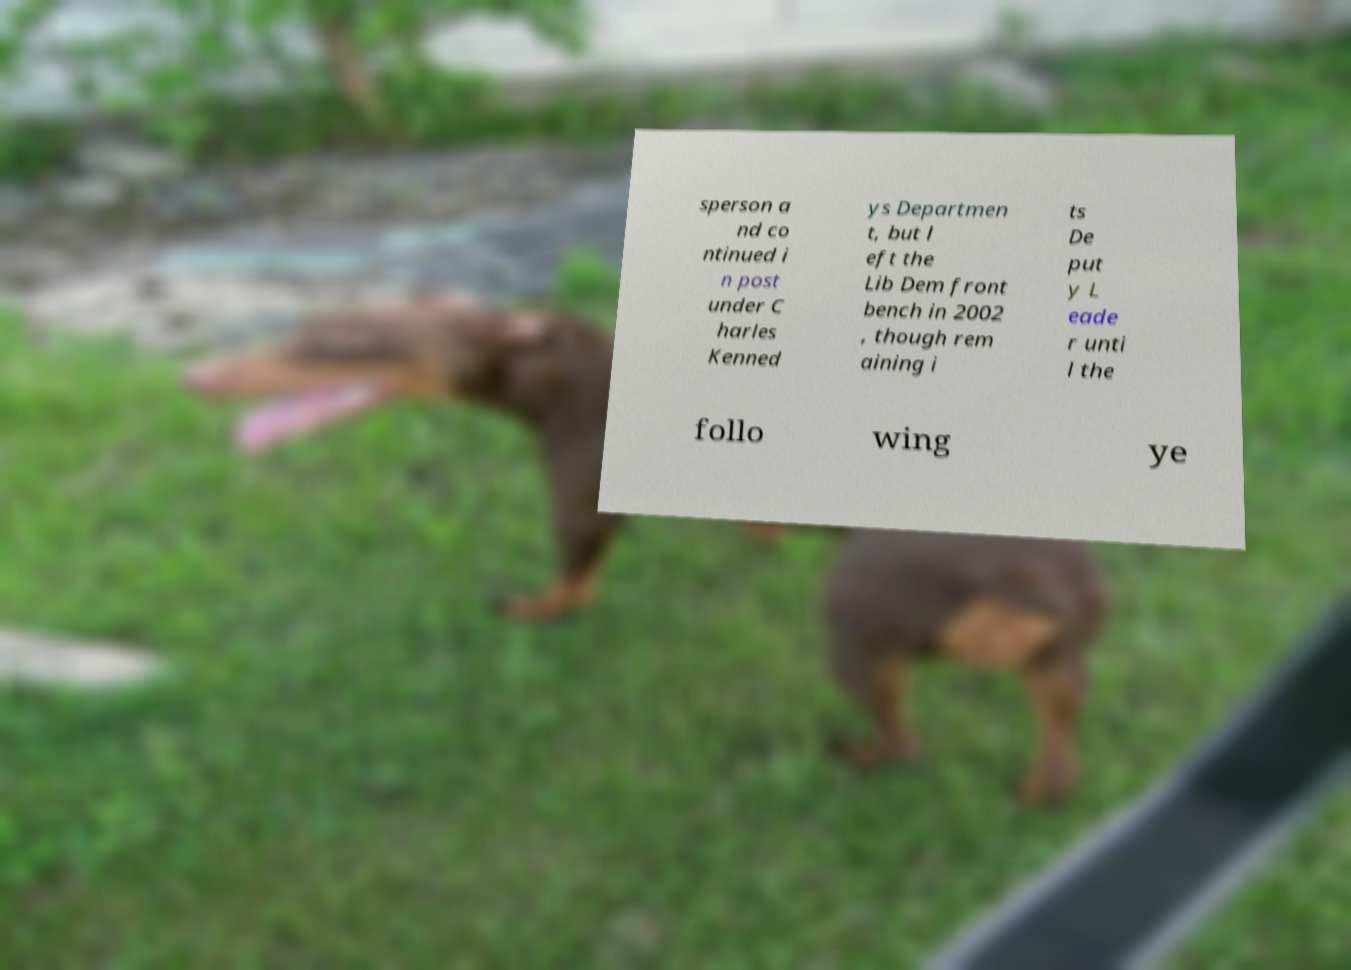For documentation purposes, I need the text within this image transcribed. Could you provide that? sperson a nd co ntinued i n post under C harles Kenned ys Departmen t, but l eft the Lib Dem front bench in 2002 , though rem aining i ts De put y L eade r unti l the follo wing ye 